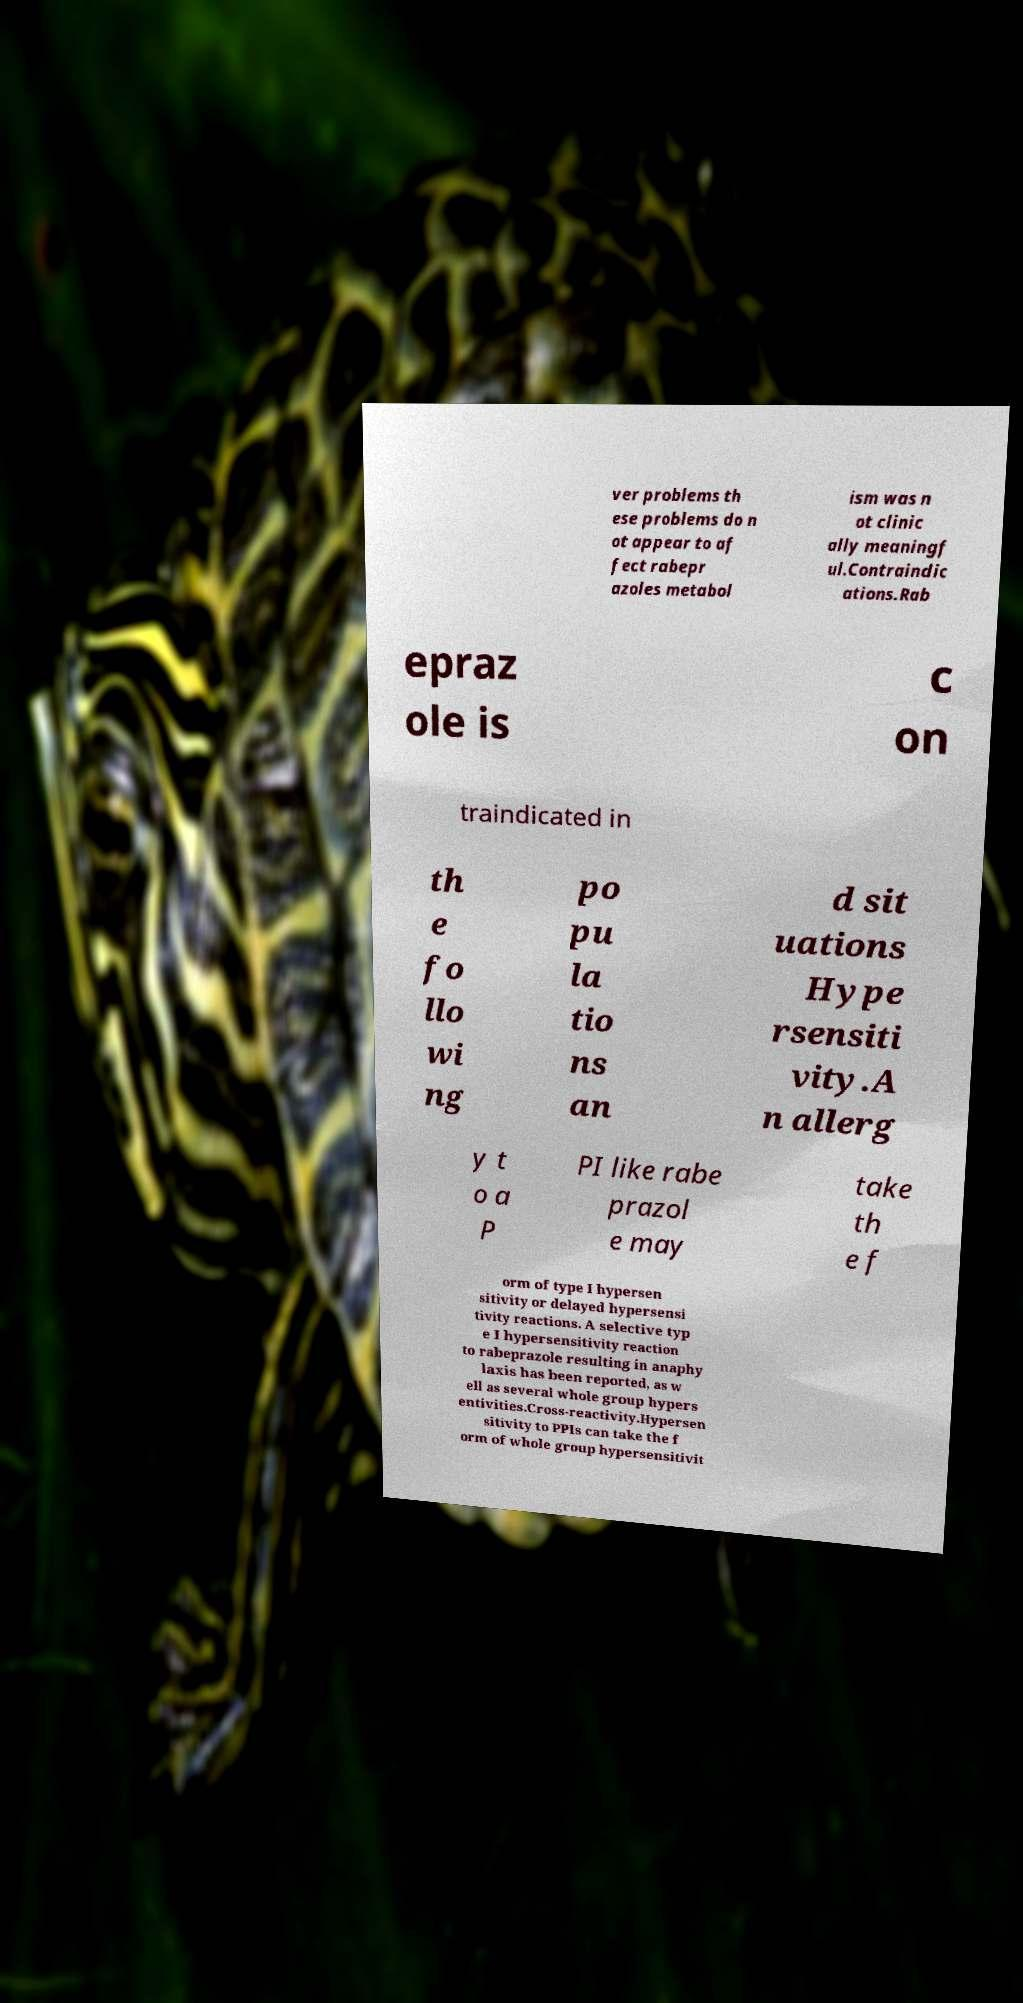Please read and relay the text visible in this image. What does it say? ver problems th ese problems do n ot appear to af fect rabepr azoles metabol ism was n ot clinic ally meaningf ul.Contraindic ations.Rab epraz ole is c on traindicated in th e fo llo wi ng po pu la tio ns an d sit uations Hype rsensiti vity.A n allerg y t o a P PI like rabe prazol e may take th e f orm of type I hypersen sitivity or delayed hypersensi tivity reactions. A selective typ e I hypersensitivity reaction to rabeprazole resulting in anaphy laxis has been reported, as w ell as several whole group hypers entivities.Cross-reactivity.Hypersen sitivity to PPIs can take the f orm of whole group hypersensitivit 